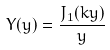<formula> <loc_0><loc_0><loc_500><loc_500>Y ( y ) = \frac { J _ { 1 } ( k y ) } { y }</formula> 